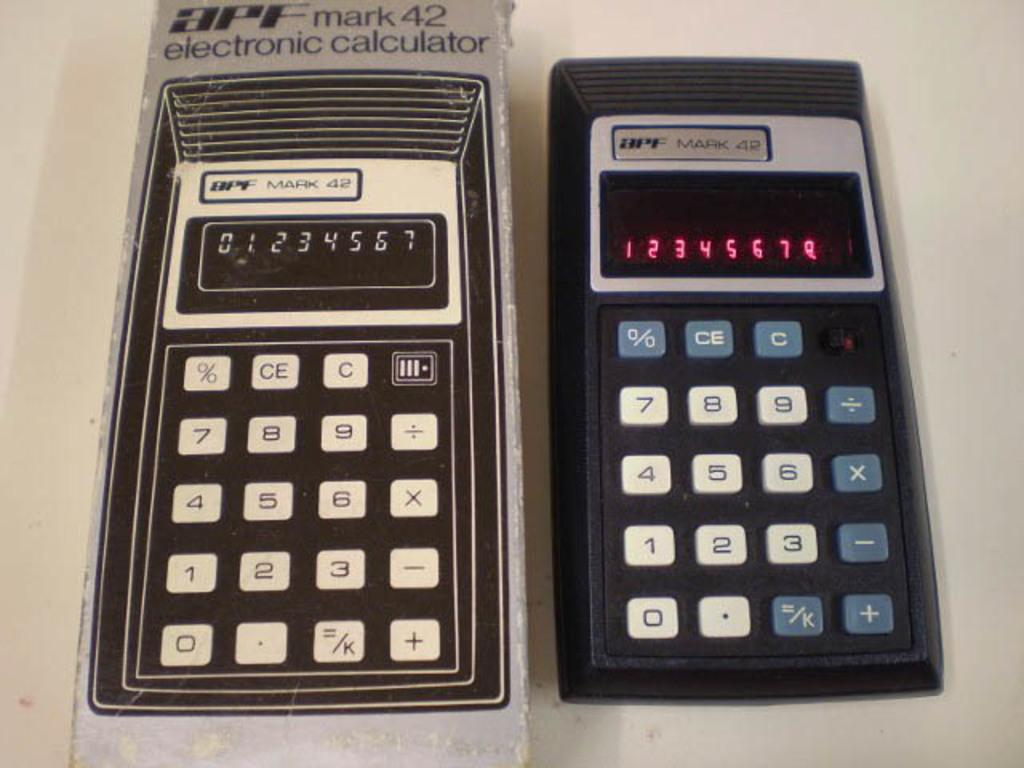<image>
Offer a succinct explanation of the picture presented. A calculator removed from its box reading 1,2,3,4,5,6,7,8 upon its display. 